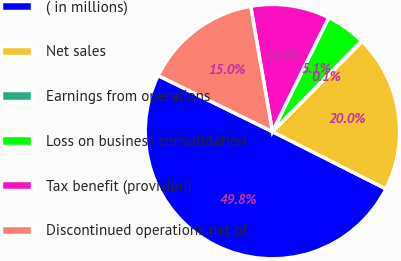Convert chart. <chart><loc_0><loc_0><loc_500><loc_500><pie_chart><fcel>( in millions)<fcel>Net sales<fcel>Earnings from operations<fcel>Loss on business consolidation<fcel>Tax benefit (provision)<fcel>Discontinued operations net of<nl><fcel>49.83%<fcel>19.98%<fcel>0.09%<fcel>5.06%<fcel>10.03%<fcel>15.01%<nl></chart> 